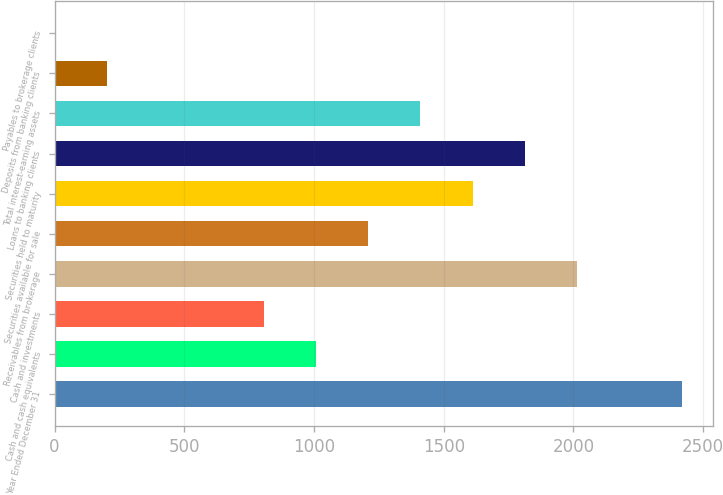Convert chart. <chart><loc_0><loc_0><loc_500><loc_500><bar_chart><fcel>Year Ended December 31<fcel>Cash and cash equivalents<fcel>Cash and investments<fcel>Receivables from brokerage<fcel>Securities available for sale<fcel>Securities held to maturity<fcel>Loans to banking clients<fcel>Total interest-earning assets<fcel>Deposits from banking clients<fcel>Payables to brokerage clients<nl><fcel>2416.81<fcel>1007.01<fcel>805.61<fcel>2014.01<fcel>1208.41<fcel>1611.21<fcel>1812.61<fcel>1409.81<fcel>201.41<fcel>0.01<nl></chart> 